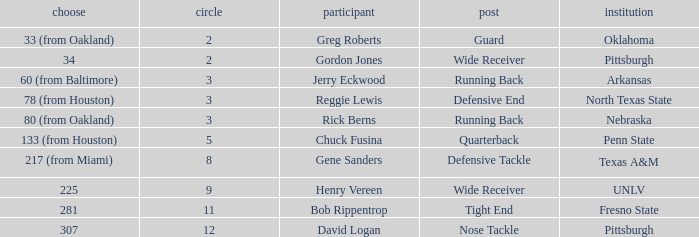What round was the nose tackle drafted? 12.0. 